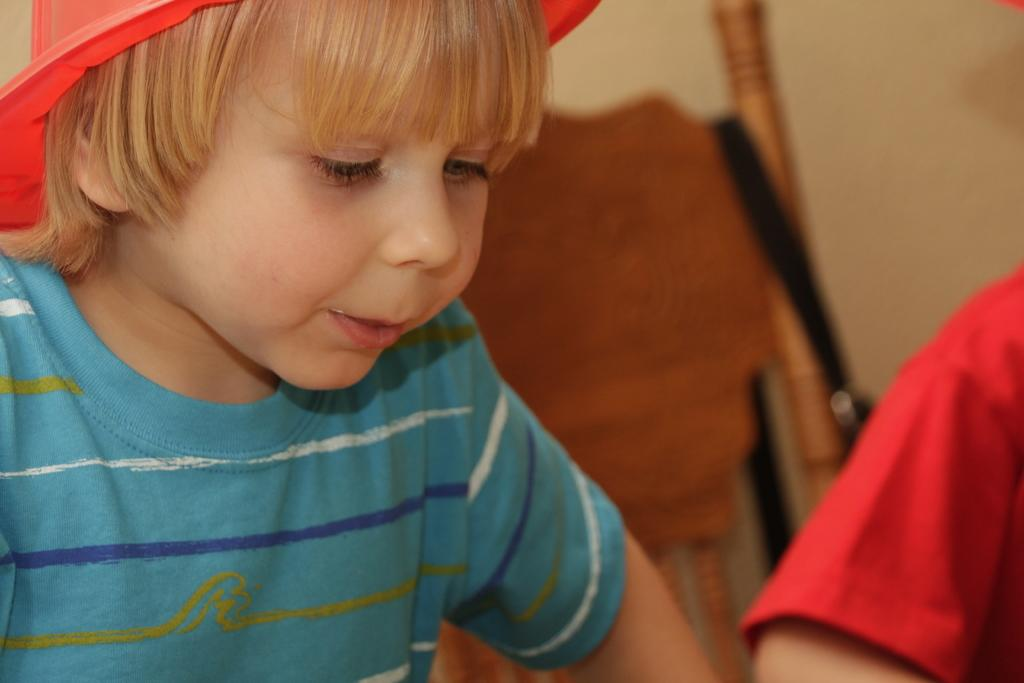Who is the main subject in the image? There is a boy in the image. What is the boy wearing on his upper body? The boy is wearing a t-shirt. What type of headwear is the boy wearing? The boy is wearing a hat. Can you describe the background of the image? The background of the image is blurred. Is there any indication of another person in the image? Yes, there is a person's hand visible in the background of the image. What type of calendar can be seen hanging on the bridge in the image? There is no calendar or bridge present in the image; it features a boy wearing a t-shirt and hat. 